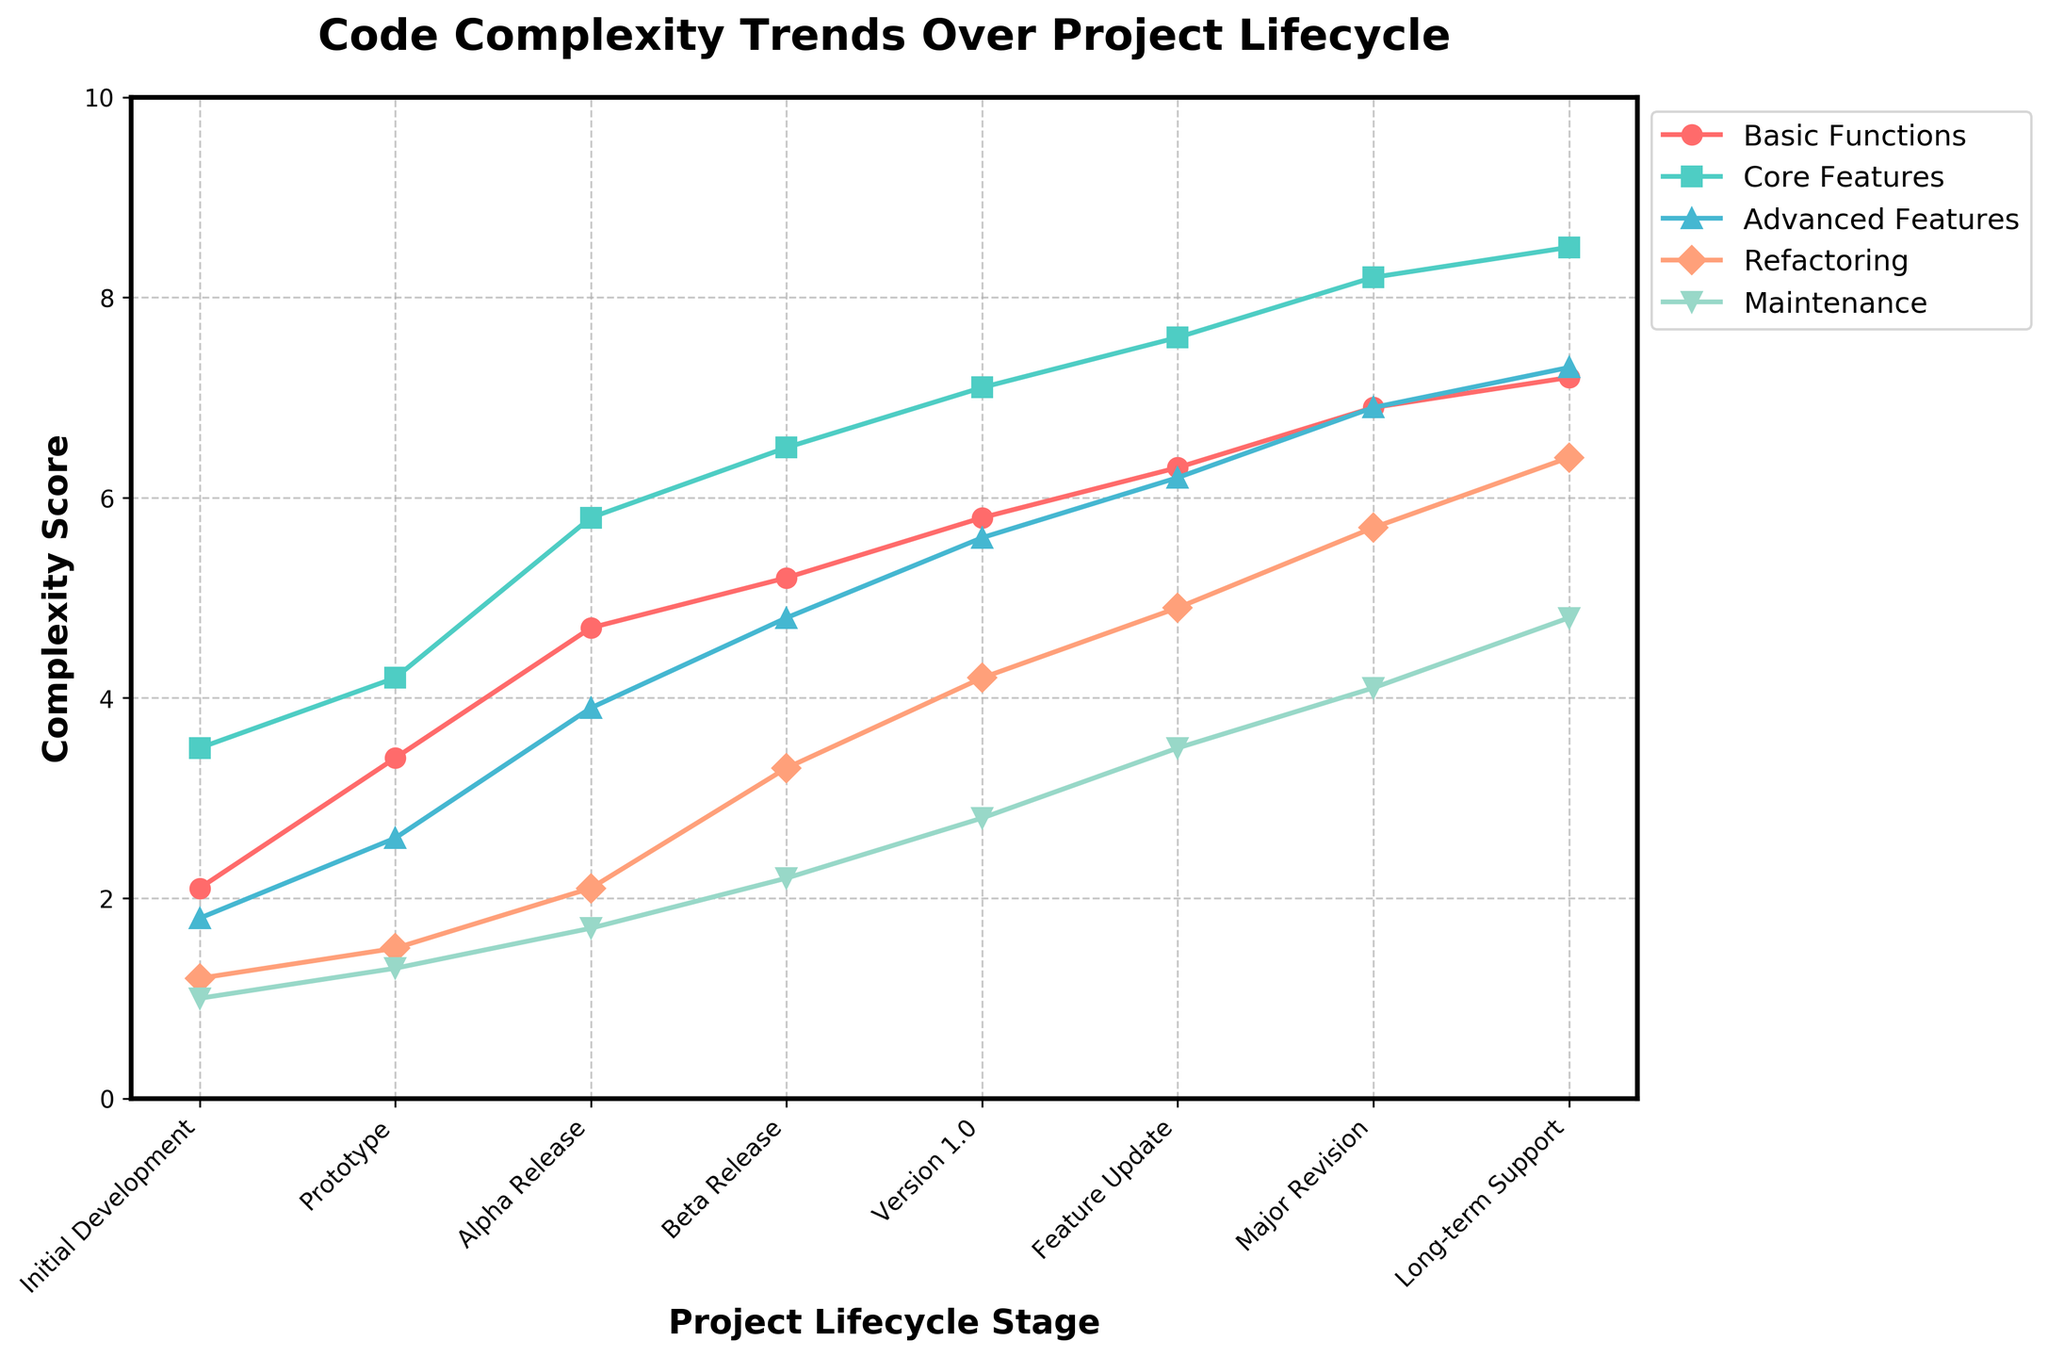How does the complexity of core features change from the Prototype stage to the Major Revision stage? Look at the data points for Core Features in the Prototype stage (4.2) and Major Revision stage (8.2) and calculate the difference: 8.2 - 4.2 = 4.0.
Answer: It increases by 4.0 Which project lifecycle stage has the highest complexity for Advanced Features, and what is the value? Identify the highest point in the Advanced Features line on the chart, which is at Long-term Support with a value of 7.3.
Answer: Long-term Support, 7.3 Is the complexity of Basic Functions at the Beta Release stage higher or lower than in the Alpha Release stage, and by how much? Compare the complexity of Basic Functions at Beta Release (5.2) and Alpha Release (4.7): 5.2 - 4.7 = 0.5.
Answer: Higher by 0.5 What is the average complexity for Maintenance across all stages? Sum all the Maintenance values and divide by the number of stages: (1.0 + 1.3 + 1.7 + 2.2 + 2.8 + 3.5 + 4.1 + 4.8) / 8 = 2.675.
Answer: 2.675 Which feature shows the steepest increase in complexity from Initial Development to Version 1.0? Calculate the differences for each feature from Initial Development to Version 1.0 and compare them to find the largest: 
Basic Functions: 5.8 - 2.1 = 3.7,
Core Features: 7.1 - 3.5 = 3.6,
Advanced Features: 5.6 - 1.8 = 3.8,
Refactoring: 4.2 - 1.2 = 3.0,
Maintenance: 2.8 - 1.0 = 1.8.
Answer: Advanced Features At which stage is the complexity of Refactoring closest to the complexity of Core Features? Compare the values of Refactoring and Core Features line by line and find the closest pair. The smallest difference is observed at Prototype: Refactoring (1.5) and Core Features (4.2) with a difference of 2.7. This isn't very close, but it's the best match.
Answer: Prototype By how much does the complexity of Advanced Features increase from Alpha Release to Long-term Support? Look at the values for Advanced Features at Alpha Release (3.9) and Long-term Support (7.3) and calculate the difference: 7.3 - 3.9 = 3.4.
Answer: By 3.4 What is the total complexity score of Basic Functions for all stages combined? Add up all the Basic Functions values: 2.1 + 3.4 + 4.7 + 5.2 + 5.8 + 6.3 + 6.9 + 7.2 = 41.6.
Answer: 41.6 Which stage shows the smallest complexity score for Refactoring, and what is the score? Identify the smallest data point in the Refactoring line, which is at Initial Development with a score of 1.2.
Answer: Initial Development, 1.2 